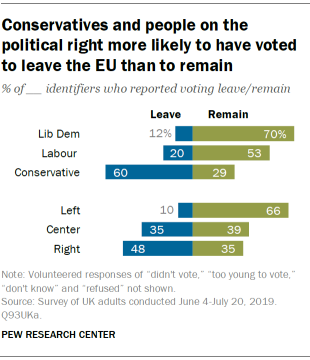Mention a couple of crucial points in this snapshot. The sum value of Remain and Leave in the Conservative Party is 89. It is known that the color green represents the political ideology of Remain. 